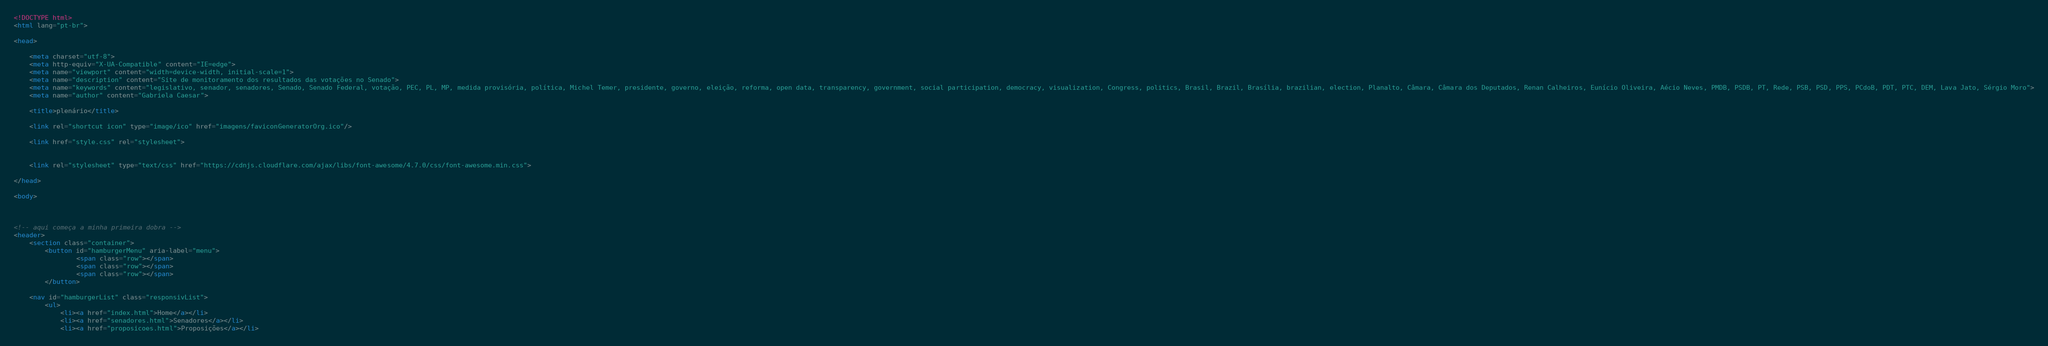Convert code to text. <code><loc_0><loc_0><loc_500><loc_500><_HTML_><!DOCTYPE html>
<html lang="pt-br">

<head>

    <meta charset="utf-8">
    <meta http-equiv="X-UA-Compatible" content="IE=edge">
    <meta name="viewport" content="width=device-width, initial-scale=1">
    <meta name="description" content="Site de monitoramento dos resultados das votações no Senado">
    <meta name="keywords" content="legislativo, senador, senadores, Senado, Senado Federal, votação, PEC, PL, MP, medida provisória, política, Michel Temer, presidente, governo, eleição, reforma, open data, transparency, government, social participation, democracy, visualization, Congress, politics, Brasil, Brazil, Brasília, brazilian, election, Planalto, Câmara, Câmara dos Deputados, Renan Calheiros, Eunício Oliveira, Aécio Neves, PMDB, PSDB, PT, Rede, PSB, PSD, PPS, PCdoB, PDT, PTC, DEM, Lava Jato, Sérgio Moro">
    <meta name="author" content="Gabriela Caesar">

    <title>plenário</title>

	<link rel="shortcut icon" type="image/ico" href="imagens/faviconGeneratorOrg.ico"/>

    <link href="style.css" rel="stylesheet">

 
    <link rel="stylesheet" type="text/css" href="https://cdnjs.cloudflare.com/ajax/libs/font-awesome/4.7.0/css/font-awesome.min.css">
    
</head>

<body>
	
	

<!-- aqui começa a minha primeira dobra -->
<header>
	<section class="container">
		<button id="hamburgerMenu" aria-label="menu">
				<span class="row"></span>
				<span class="row"></span>
				<span class="row"></span>
		</button>

	<nav id="hamburgerList" class="responsivList">
		<ul>
			<li><a href="index.html">Home</a></li>
			<li><a href="senadores.html">Senadores</a></li>
			<li><a href="proposicoes.html">Proposições</a></li></code> 